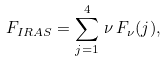Convert formula to latex. <formula><loc_0><loc_0><loc_500><loc_500>F _ { I R A S } = \sum _ { j = 1 } ^ { 4 } \, \nu \, F _ { \nu } ( j ) ,</formula> 